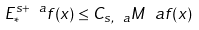<formula> <loc_0><loc_0><loc_500><loc_500>E _ { * } ^ { s + \ a } f ( x ) \leq C _ { s , \ a } M ^ { \ } a f ( x )</formula> 